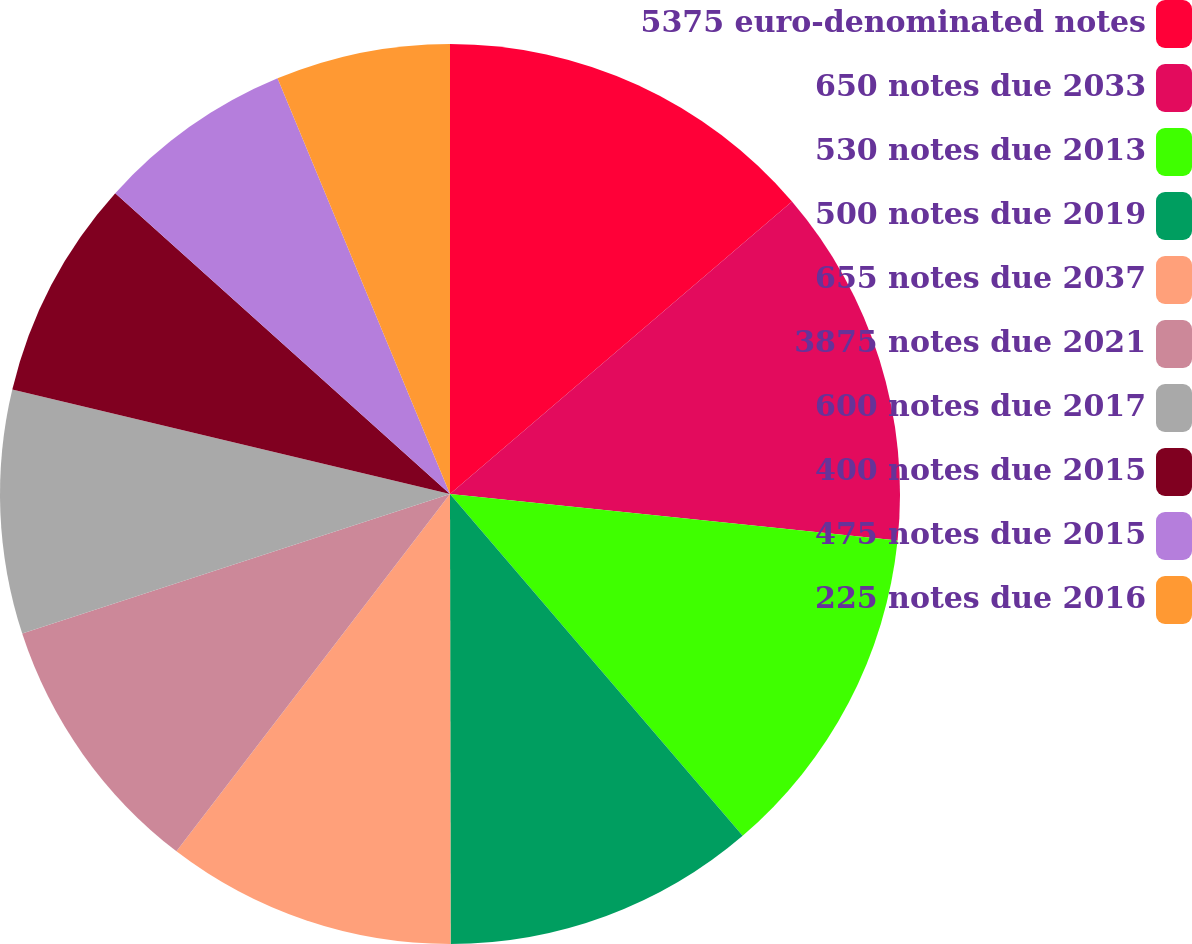Convert chart. <chart><loc_0><loc_0><loc_500><loc_500><pie_chart><fcel>5375 euro-denominated notes<fcel>650 notes due 2033<fcel>530 notes due 2013<fcel>500 notes due 2019<fcel>655 notes due 2037<fcel>3875 notes due 2021<fcel>600 notes due 2017<fcel>400 notes due 2015<fcel>475 notes due 2015<fcel>225 notes due 2016<nl><fcel>13.74%<fcel>12.91%<fcel>12.08%<fcel>11.25%<fcel>10.42%<fcel>9.58%<fcel>8.75%<fcel>7.92%<fcel>7.09%<fcel>6.26%<nl></chart> 